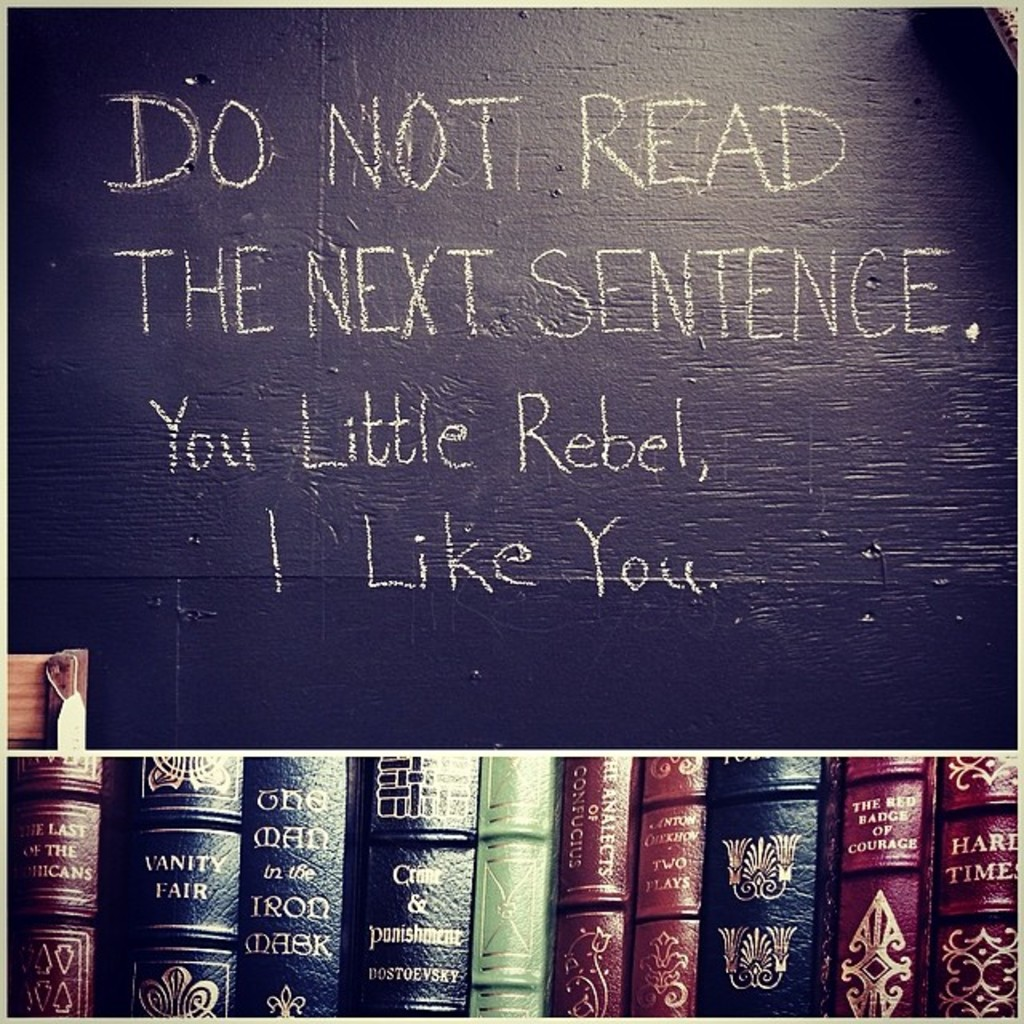What do you see happening in this image?
 The image presents a scene of a blackboard with a playful message written in white chalk. The message begins with a command, "Do not read the next sentence." This is immediately followed by a cheeky acknowledgment of the reader's disobedience, "You little rebel, I like you." The blackboard is mounted above a shelf that holds a collection of books. The books, with their colorful spines, appear to be classic literature, including titles such as "Vanity Fair" and "The Count of Monte Cristo." The image conveys a sense of humor and a love for reading. 